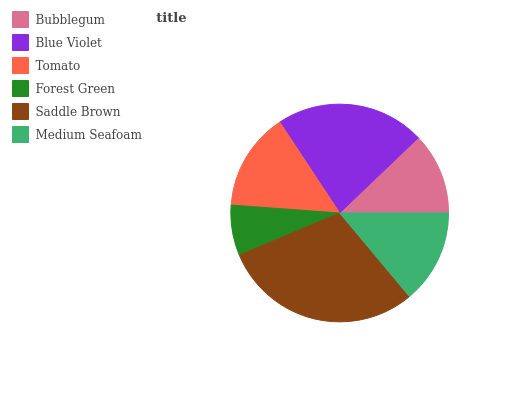Is Forest Green the minimum?
Answer yes or no. Yes. Is Saddle Brown the maximum?
Answer yes or no. Yes. Is Blue Violet the minimum?
Answer yes or no. No. Is Blue Violet the maximum?
Answer yes or no. No. Is Blue Violet greater than Bubblegum?
Answer yes or no. Yes. Is Bubblegum less than Blue Violet?
Answer yes or no. Yes. Is Bubblegum greater than Blue Violet?
Answer yes or no. No. Is Blue Violet less than Bubblegum?
Answer yes or no. No. Is Tomato the high median?
Answer yes or no. Yes. Is Medium Seafoam the low median?
Answer yes or no. Yes. Is Saddle Brown the high median?
Answer yes or no. No. Is Tomato the low median?
Answer yes or no. No. 